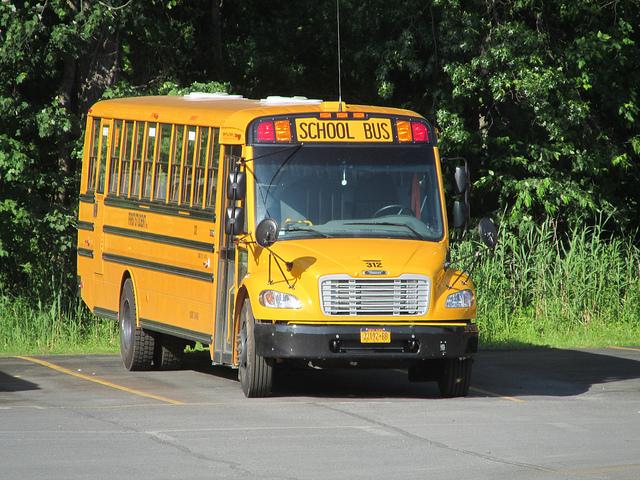What is the main color of the bus?
Quick response, please. Yellow. What does the sign  say?
Be succinct. School bus. Where is the school bus parked?
Answer briefly. Parking lot. Where is the bus headed to?
Keep it brief. School. Are the wheels on the bus straight?
Answer briefly. Yes. How far do you have to keep back from the bus?
Be succinct. 10 feet. 